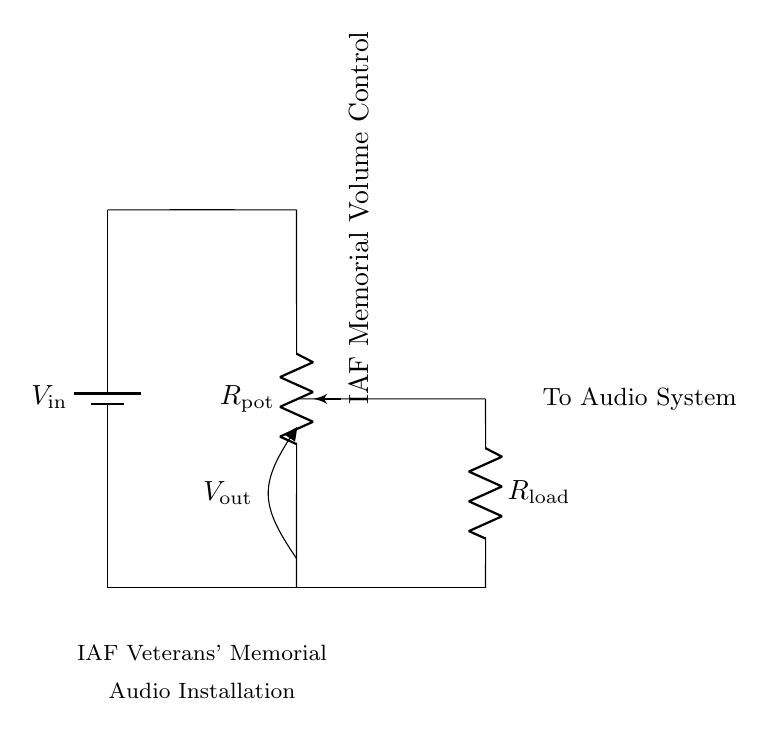What is the type of potentiometer used here? The circuit diagram labels the potentiometer as 'R_pot', which indicates it's a variable resistor. Specifically, it is shown with a description that denotes its function as the volume control for the audio system.
Answer: IAF Memorial Volume Control What is the input voltage denoted in the circuit? The circuit depicts a battery labeled 'V_in' which represents the input voltage supplied to the circuit. While the specific voltage value is not detailed in the diagram, the notation clearly indicates the presence of an input voltage source.
Answer: V_in What is connected to the output of the voltage divider? The circuit diagram shows that the output 'V_out' is connected to the audio system. The annotation near that point explicitly states, "To Audio System," identifying what receives the divided voltage.
Answer: Audio System How many resistors are visible in the circuit? There are two resistors indicated in the circuit: one is the potentiometer labeled 'R_pot' and the other is the load resistor labeled 'R_load'. Both play a role in the voltage division.
Answer: Two What is the purpose of the load resistor in this circuit? The load resistor 'R_load' is designed to receive the divided voltage output from the potentiometer. It becomes integral in how the output voltage 'V_out' is perceived by the audio system.
Answer: To receive V_out What does V_out represent in this circuit? The 'V_out' labeled in the diagram represents the output voltage taken from the voltage divider circuit, which varies based on the position of the potentiometer 'R_pot'. As the potentiometer adjusts, 'V_out' controls the volume for the audio installations.
Answer: Output voltage 